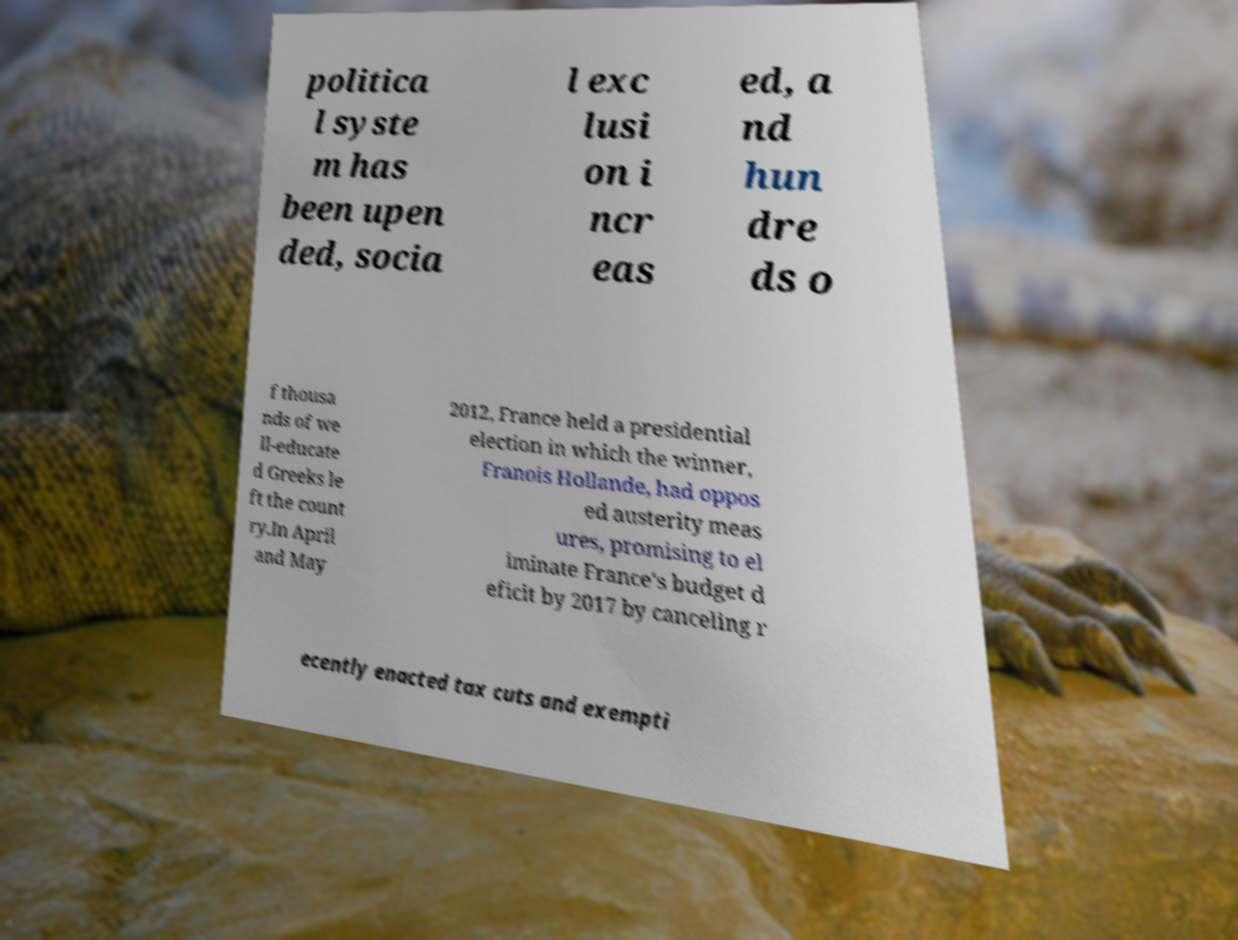Can you accurately transcribe the text from the provided image for me? politica l syste m has been upen ded, socia l exc lusi on i ncr eas ed, a nd hun dre ds o f thousa nds of we ll-educate d Greeks le ft the count ry.In April and May 2012, France held a presidential election in which the winner, Franois Hollande, had oppos ed austerity meas ures, promising to el iminate France's budget d eficit by 2017 by canceling r ecently enacted tax cuts and exempti 